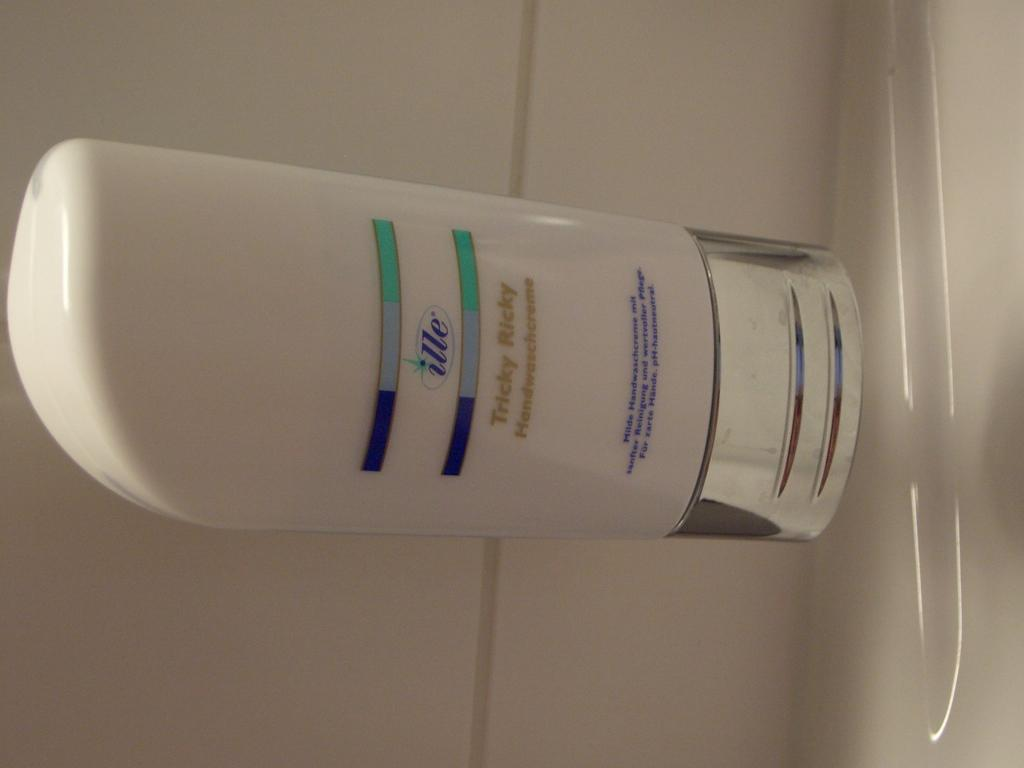<image>
Provide a brief description of the given image. A white bottle of Ille hand soap sits on a white surface. 